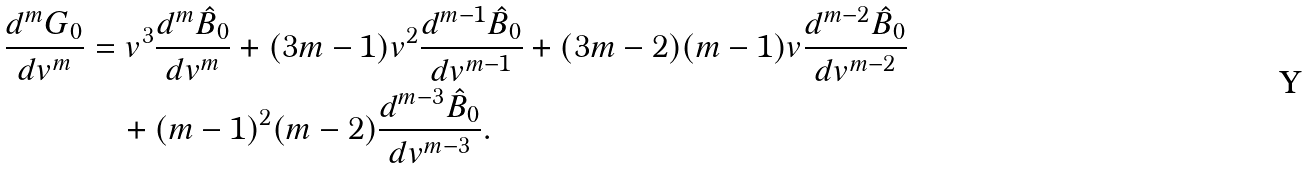Convert formula to latex. <formula><loc_0><loc_0><loc_500><loc_500>\frac { d ^ { m } G _ { 0 } } { d v ^ { m } } & = v ^ { 3 } \frac { d ^ { m } \hat { B } _ { 0 } } { d v ^ { m } } + ( 3 m - 1 ) v ^ { 2 } \frac { d ^ { m - 1 } \hat { B } _ { 0 } } { d v ^ { m - 1 } } + ( 3 m - 2 ) ( m - 1 ) v \frac { d ^ { m - 2 } \hat { B } _ { 0 } } { d v ^ { m - 2 } } \\ & \quad + ( m - 1 ) ^ { 2 } ( m - 2 ) \frac { d ^ { m - 3 } \hat { B } _ { 0 } } { d v ^ { m - 3 } } .</formula> 